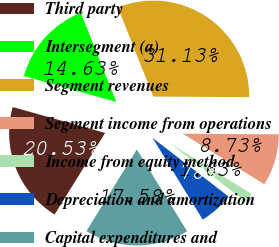Convert chart to OTSL. <chart><loc_0><loc_0><loc_500><loc_500><pie_chart><fcel>Third party<fcel>Intersegment (a)<fcel>Segment revenues<fcel>Segment income from operations<fcel>Income from equity method<fcel>Depreciation and amortization<fcel>Capital expenditures and<nl><fcel>20.53%<fcel>14.63%<fcel>31.13%<fcel>8.73%<fcel>1.63%<fcel>5.78%<fcel>17.58%<nl></chart> 